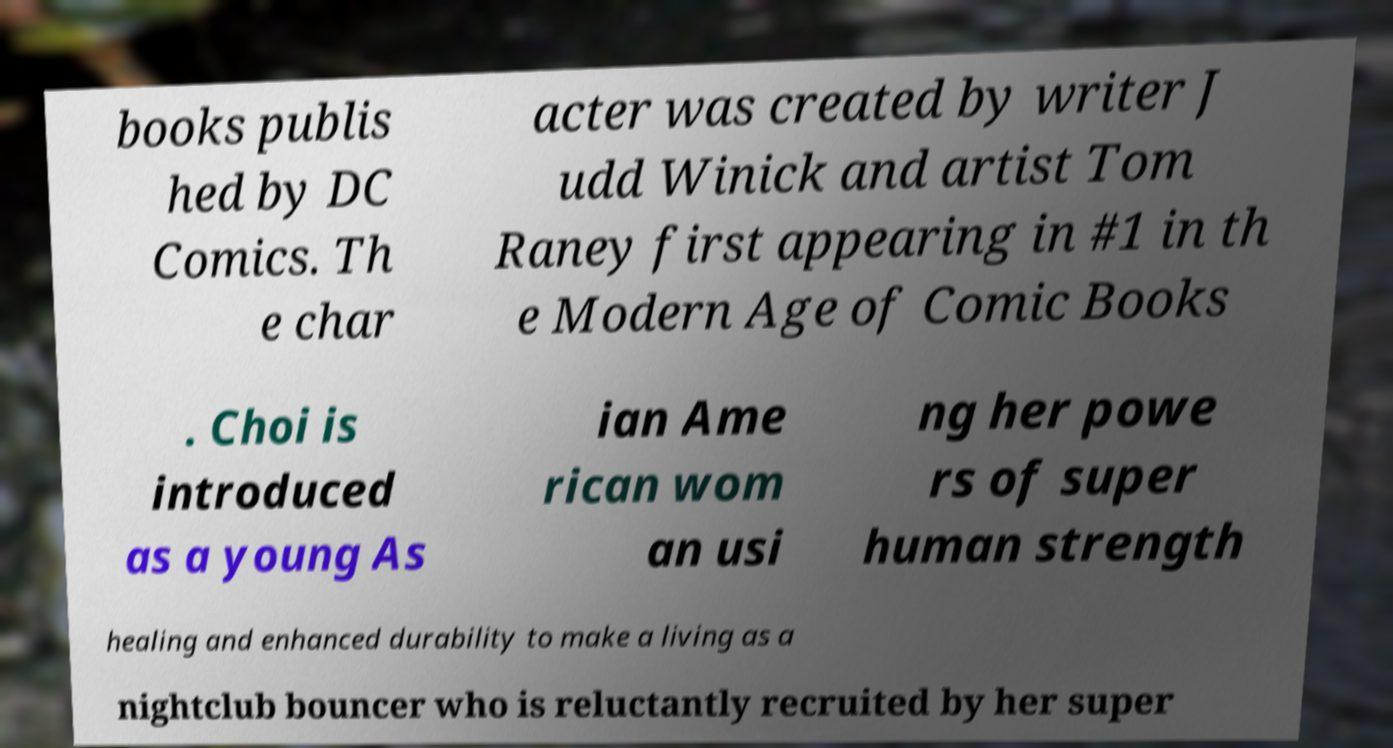Please identify and transcribe the text found in this image. books publis hed by DC Comics. Th e char acter was created by writer J udd Winick and artist Tom Raney first appearing in #1 in th e Modern Age of Comic Books . Choi is introduced as a young As ian Ame rican wom an usi ng her powe rs of super human strength healing and enhanced durability to make a living as a nightclub bouncer who is reluctantly recruited by her super 